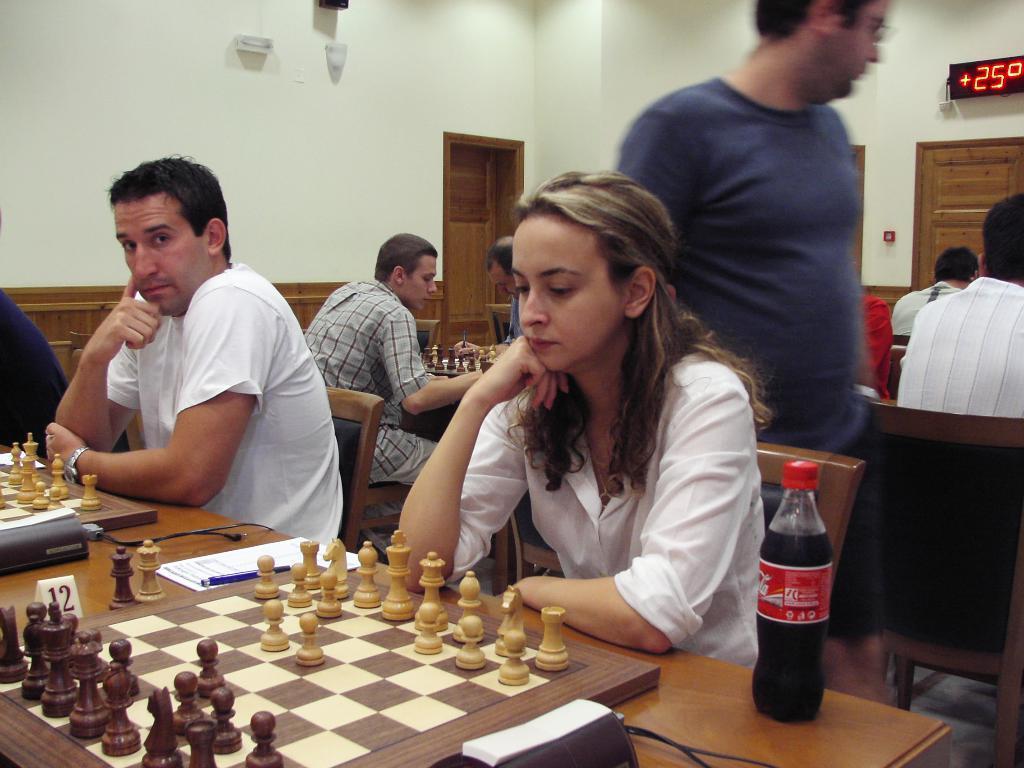Can you describe this image briefly? This picture shows few people seated and playing chess on the chess board and we see a coke bottle and a man standing and watching them 